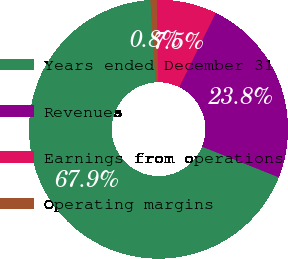Convert chart. <chart><loc_0><loc_0><loc_500><loc_500><pie_chart><fcel>Years ended December 31<fcel>Revenues<fcel>Earnings from operations<fcel>Operating margins<nl><fcel>67.94%<fcel>23.79%<fcel>7.49%<fcel>0.78%<nl></chart> 